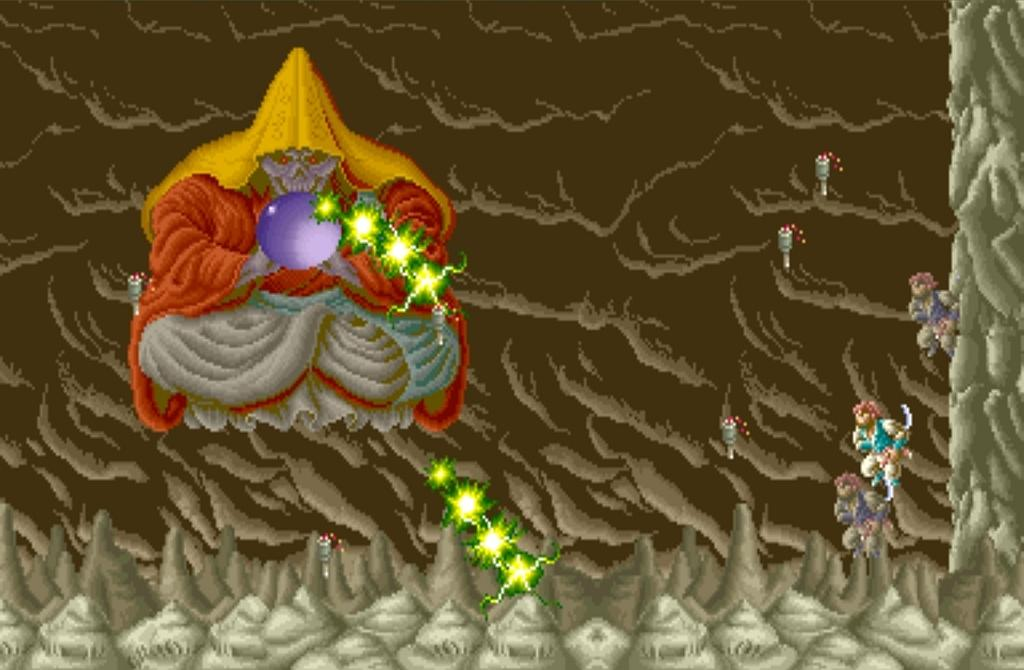What is the main subject of the image? The main subject of the image is a painting. What can be seen in the painting? The painting contains persons, balls, lights, and other objects. What type of jewel is being displayed in the painting? There is no jewel present in the painting; it contains persons, balls, lights, and other objects. 